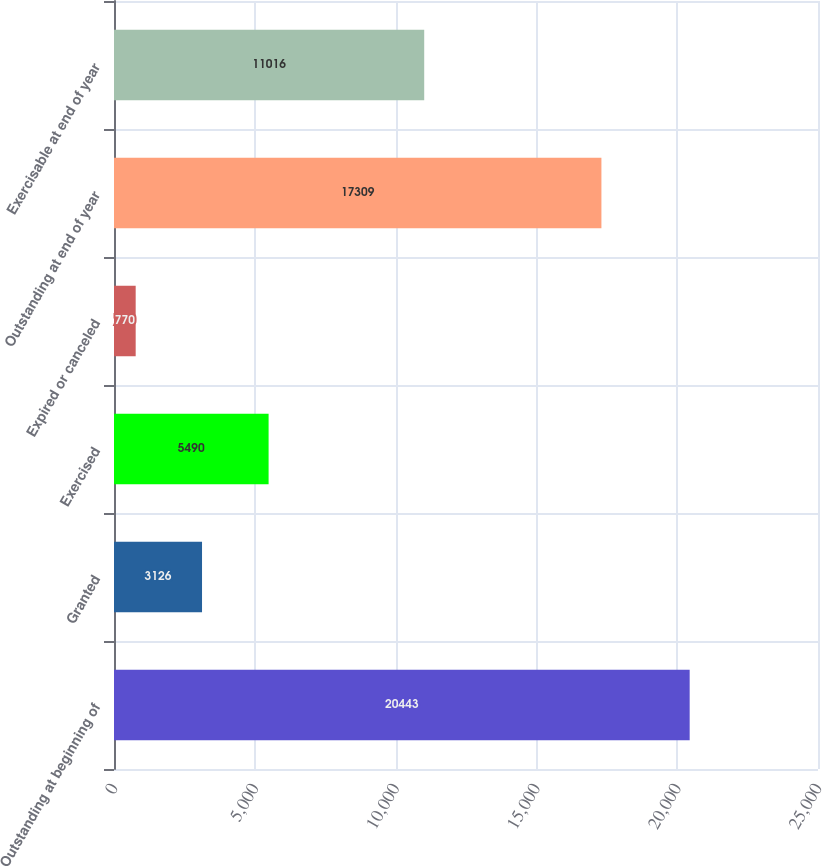Convert chart. <chart><loc_0><loc_0><loc_500><loc_500><bar_chart><fcel>Outstanding at beginning of<fcel>Granted<fcel>Exercised<fcel>Expired or canceled<fcel>Outstanding at end of year<fcel>Exercisable at end of year<nl><fcel>20443<fcel>3126<fcel>5490<fcel>770<fcel>17309<fcel>11016<nl></chart> 